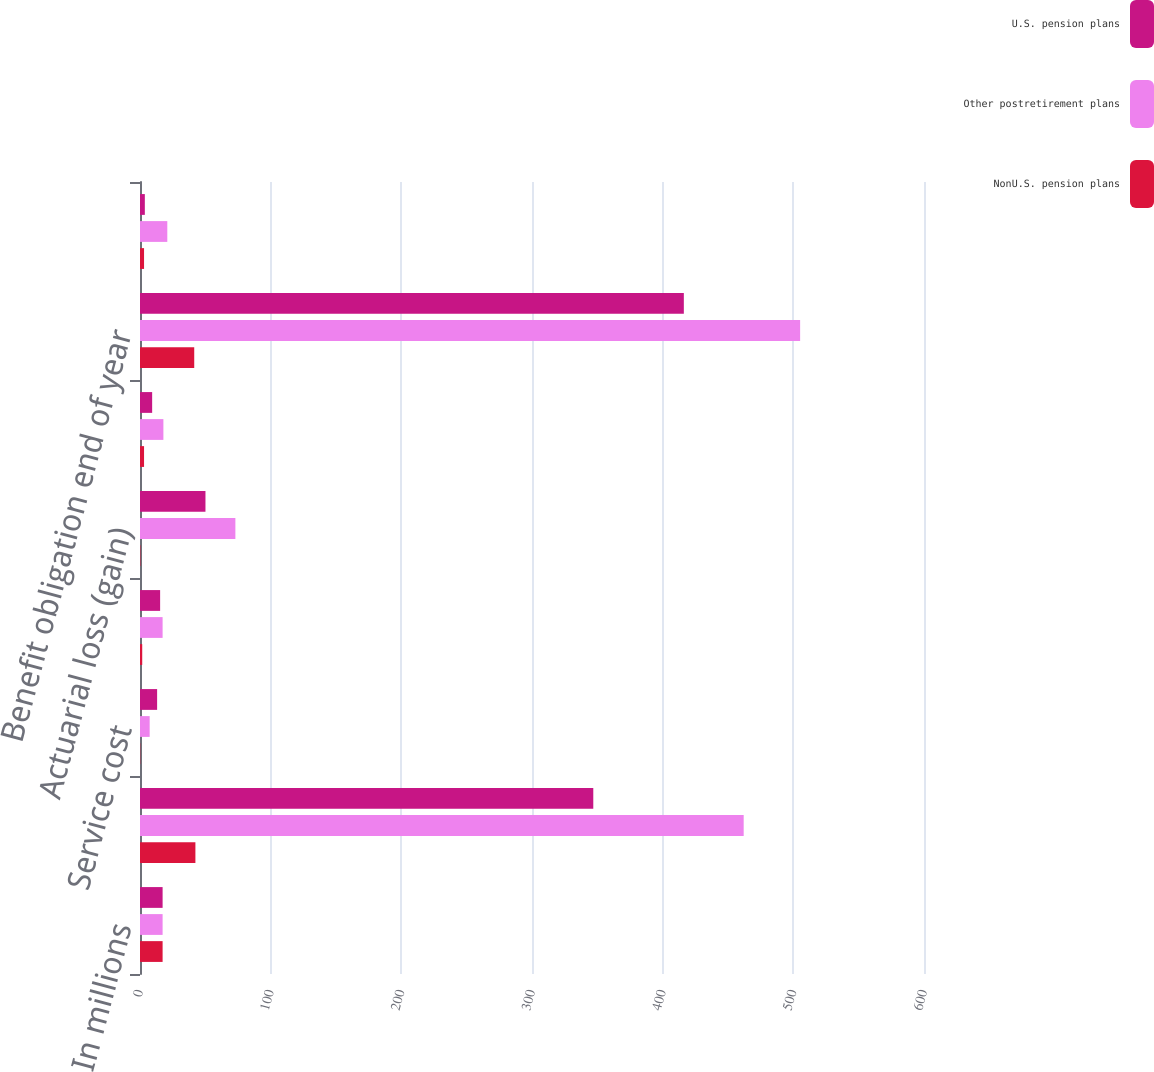Convert chart. <chart><loc_0><loc_0><loc_500><loc_500><stacked_bar_chart><ecel><fcel>In millions<fcel>Benefit obligation beginning<fcel>Service cost<fcel>Interest cost<fcel>Actuarial loss (gain)<fcel>Benefits paid<fcel>Benefit obligation end of year<fcel>Company contributions<nl><fcel>U.S. pension plans<fcel>17.3<fcel>346.9<fcel>13.1<fcel>15.4<fcel>50.1<fcel>9.3<fcel>416.2<fcel>3.7<nl><fcel>Other postretirement plans<fcel>17.3<fcel>462<fcel>7.4<fcel>17.3<fcel>73<fcel>17.9<fcel>505.2<fcel>20.9<nl><fcel>NonU.S. pension plans<fcel>17.3<fcel>42.4<fcel>0.2<fcel>1.7<fcel>0.3<fcel>3.1<fcel>41.5<fcel>3.1<nl></chart> 